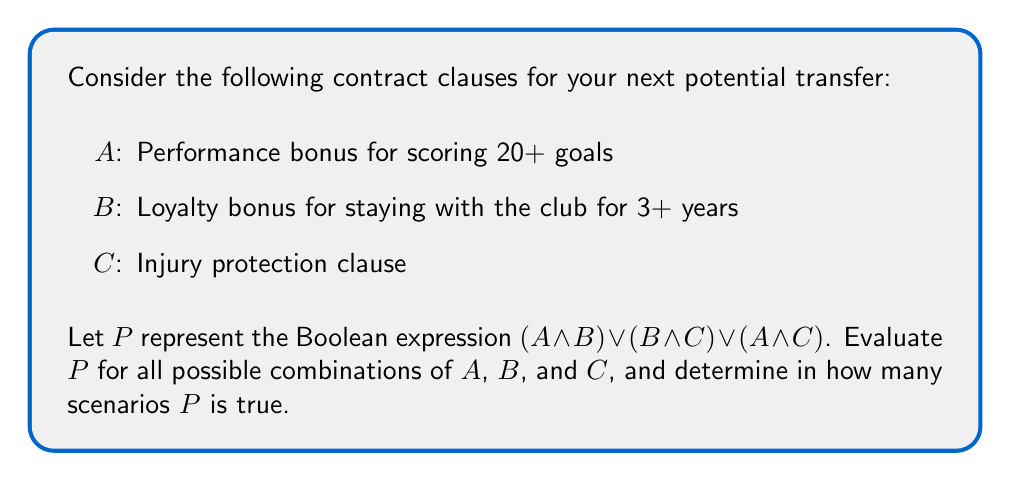Can you solve this math problem? To solve this problem, we need to create a truth table for the given Boolean expression and count the number of true outcomes.

Let's break it down step-by-step:

1) First, we'll create a truth table with all possible combinations of A, B, and C:

   A | B | C
   --|---|--
   0 | 0 | 0
   0 | 0 | 1
   0 | 1 | 0
   0 | 1 | 1
   1 | 0 | 0
   1 | 0 | 1
   1 | 1 | 0
   1 | 1 | 1

2) Now, let's evaluate each part of the expression:
   $P = (A \land B) \lor (B \land C) \lor (A \land C)$

3) We'll add columns for each sub-expression:

   A | B | C | A∧B | B∧C | A∧C | P
   --|---|---|-----|-----|-----|--
   0 | 0 | 0 |  0  |  0  |  0  | 0
   0 | 0 | 1 |  0  |  0  |  0  | 0
   0 | 1 | 0 |  0  |  0  |  0  | 0
   0 | 1 | 1 |  0  |  1  |  0  | 1
   1 | 0 | 0 |  0  |  0  |  0  | 0
   1 | 0 | 1 |  0  |  0  |  1  | 1
   1 | 1 | 0 |  1  |  0  |  0  | 1
   1 | 1 | 1 |  1  |  1  |  1  | 1

4) The final column P is true when at least one of A∧B, B∧C, or A∧C is true.

5) Counting the number of true outcomes in the P column, we get 4.

Therefore, there are 4 scenarios where the expression P is true.
Answer: 4 